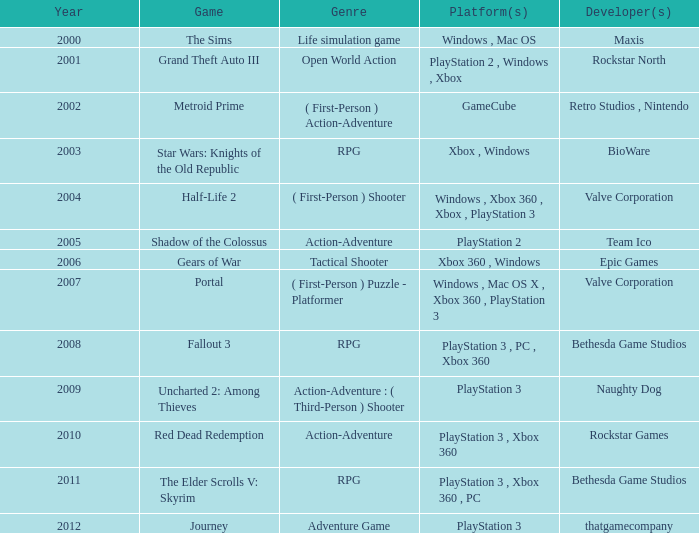What's the platform that has Rockstar Games as the developer? PlayStation 3 , Xbox 360. 